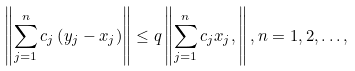<formula> <loc_0><loc_0><loc_500><loc_500>\left \| \sum _ { j = 1 } ^ { n } c _ { j } \left ( y _ { j } - x _ { j } \right ) \right \| \leq q \left \| \sum _ { j = 1 } ^ { n } c _ { j } x _ { j } , \right \| , n = 1 , 2 , \dots ,</formula> 